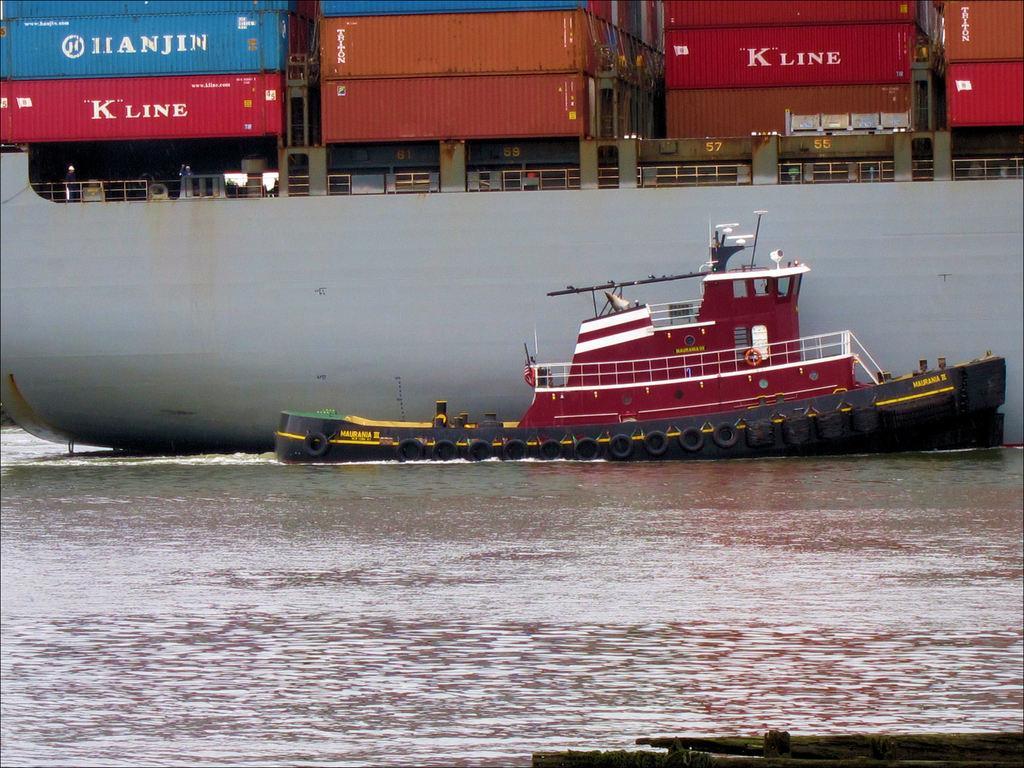Can you describe this image briefly? In this image I can see few boats. I can see few colorful containers in the ship. I can see the water. 